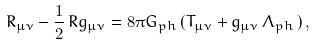<formula> <loc_0><loc_0><loc_500><loc_500>R _ { \mu \nu } - \frac { 1 } { 2 } \, R g _ { \mu \nu } = 8 \pi G _ { p h } \, ( T _ { \mu \nu } + g _ { \mu \nu } \, \Lambda _ { p h } \, ) \, ,</formula> 